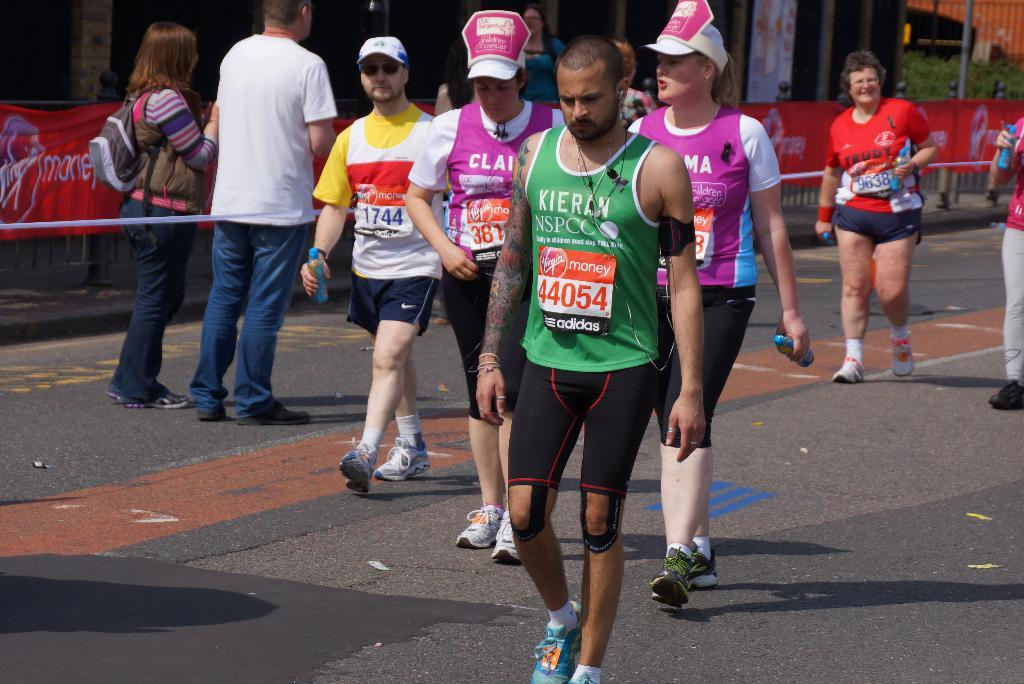What are the people in the image doing? The people in the image are walking. What can be seen hanging or displayed in the image? There is a banner in the image. What type of natural elements are present in the image? There are trees in the image. What type of man-made structures can be seen in the image? There are buildings in the image. What type of holiday is being celebrated in the image? There is no indication of a holiday being celebrated in the image. How is the fog affecting visibility in the image? There is no fog present in the image; it is clear and easy to see the people, banner, trees, and buildings. 